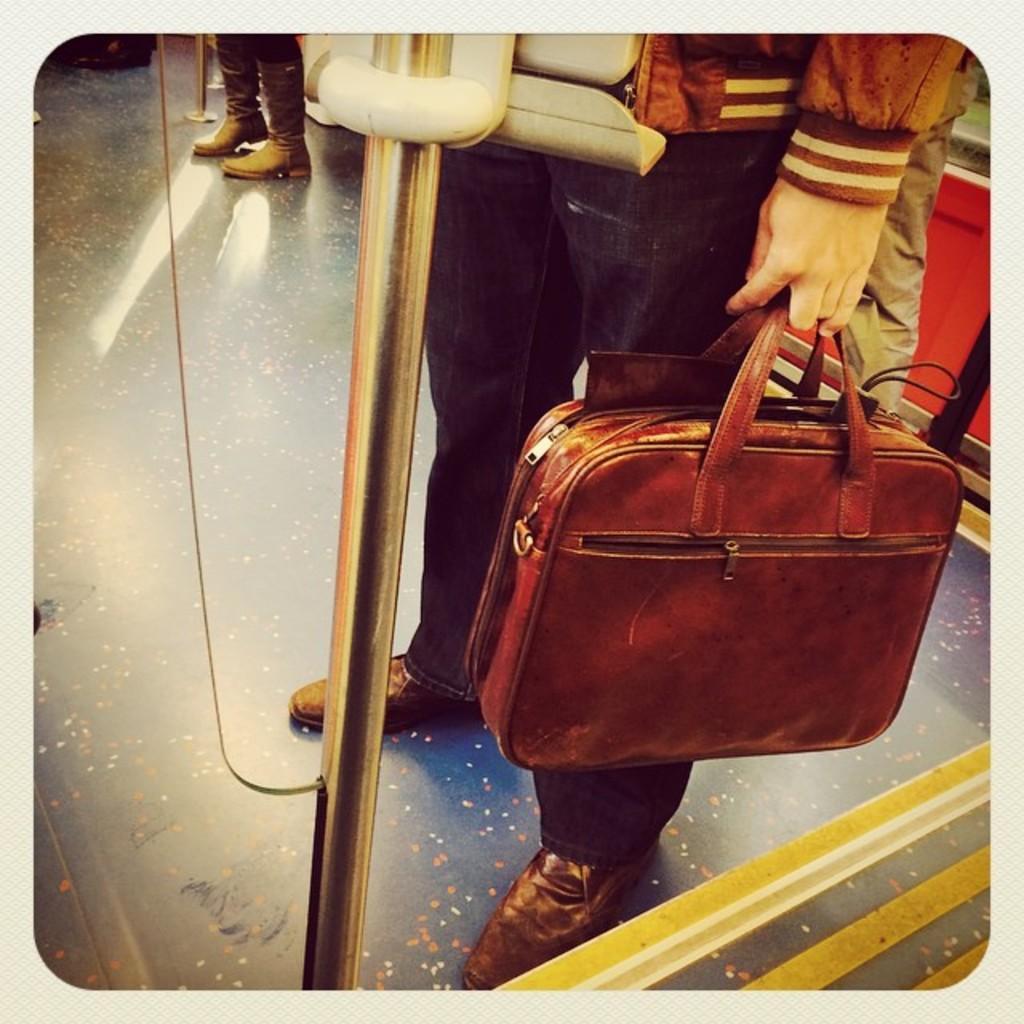Can you describe this image briefly? In this image a man is holding a bag. It is looking like the photo is taken inside a train. 